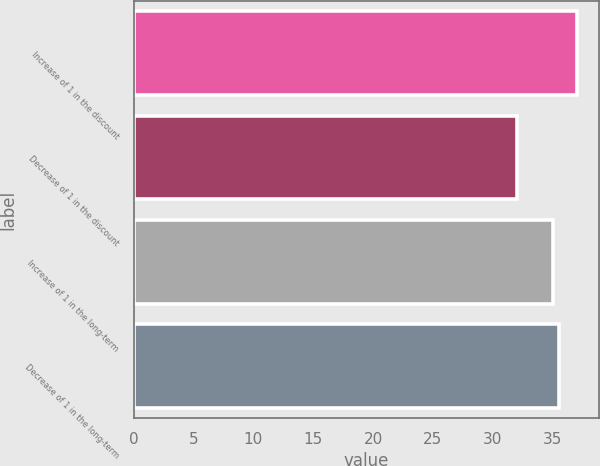Convert chart. <chart><loc_0><loc_0><loc_500><loc_500><bar_chart><fcel>Increase of 1 in the discount<fcel>Decrease of 1 in the discount<fcel>Increase of 1 in the long-term<fcel>Decrease of 1 in the long-term<nl><fcel>37<fcel>32<fcel>35<fcel>35.5<nl></chart> 